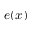<formula> <loc_0><loc_0><loc_500><loc_500>e ( x )</formula> 